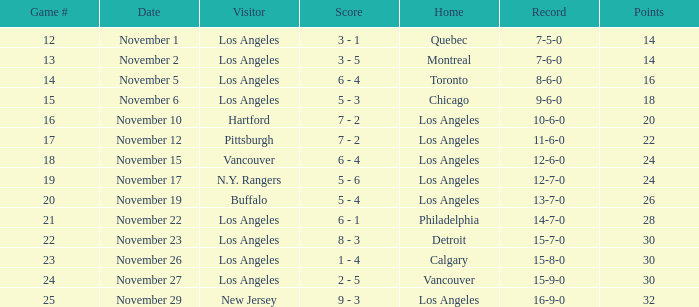What is the number of points of the game less than number 17 with an 11-6-0 record? None. 